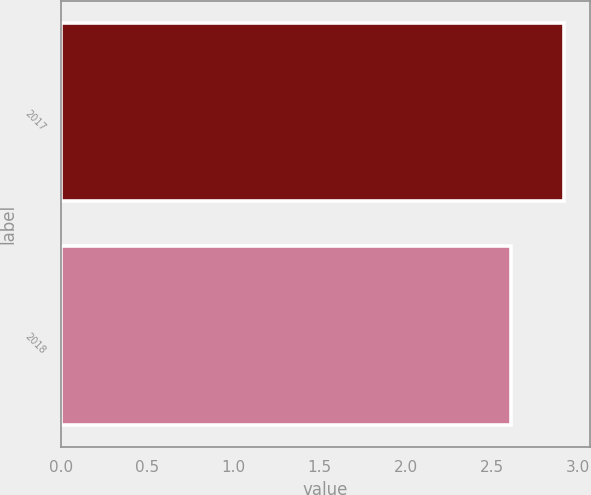Convert chart. <chart><loc_0><loc_0><loc_500><loc_500><bar_chart><fcel>2017<fcel>2018<nl><fcel>2.92<fcel>2.61<nl></chart> 